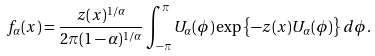Convert formula to latex. <formula><loc_0><loc_0><loc_500><loc_500>f _ { \alpha } ( x ) = \frac { z ( x ) ^ { 1 / \alpha } } { 2 \pi ( 1 - \alpha ) ^ { 1 / \alpha } } \int _ { - \pi } ^ { \pi } U _ { \alpha } ( \phi ) \exp \left \{ - z ( x ) U _ { \alpha } ( \phi ) \right \} d \phi .</formula> 